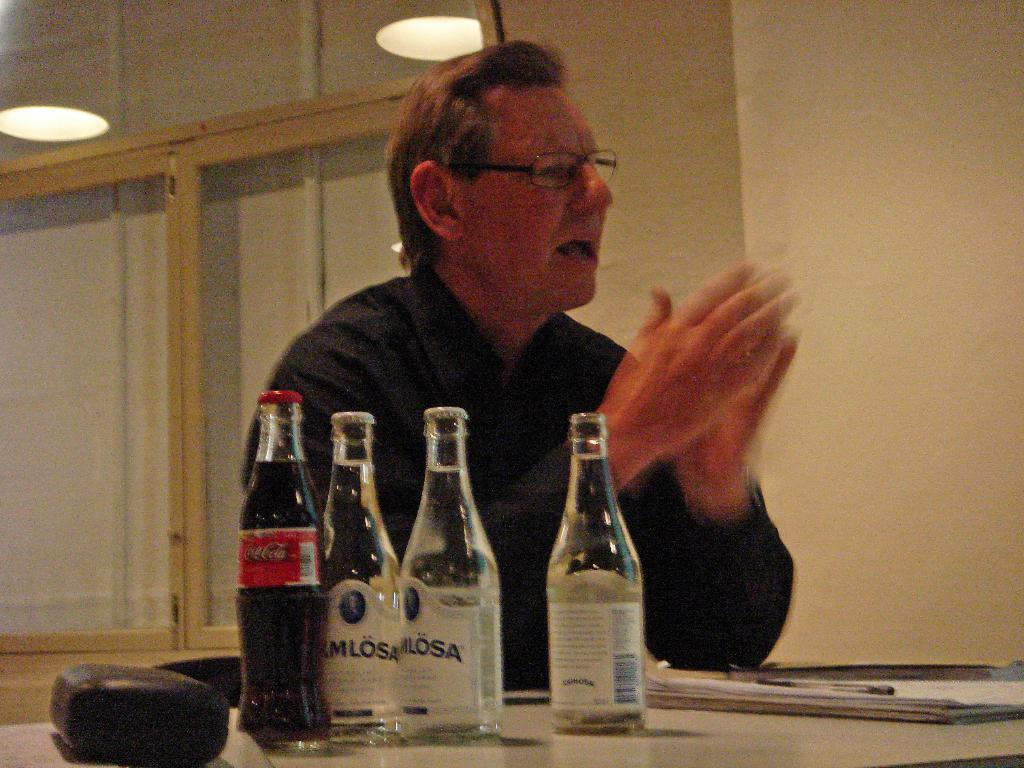<image>
Relay a brief, clear account of the picture shown. A man is sitting at a table with a bottle of Coca Cola 